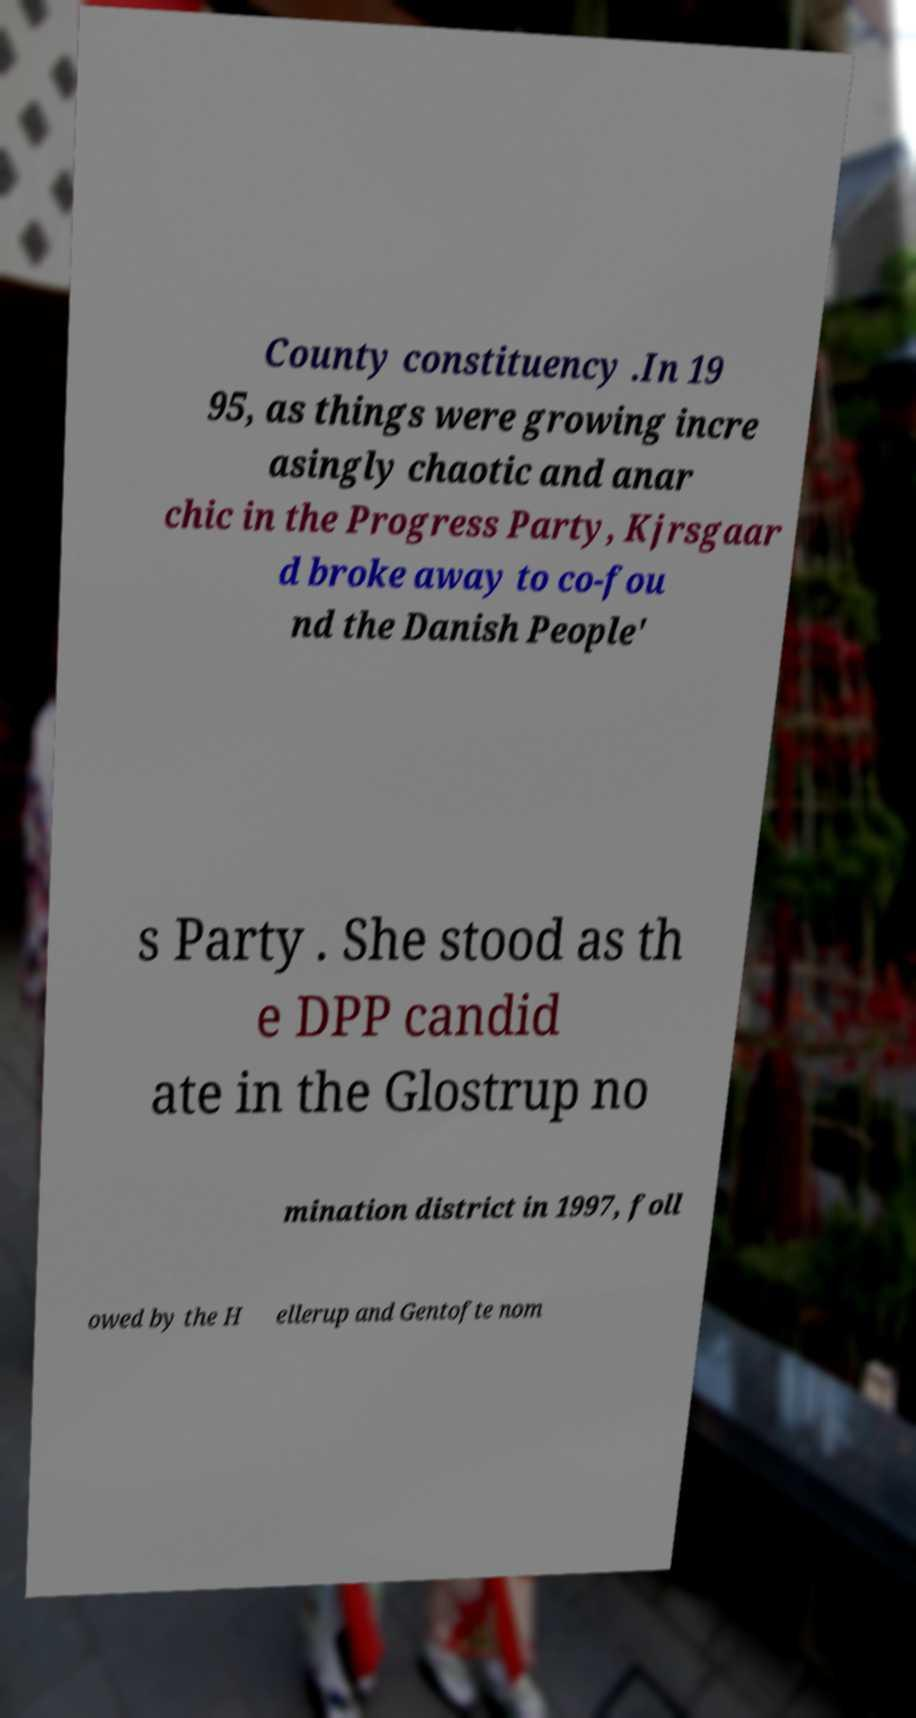Could you assist in decoding the text presented in this image and type it out clearly? County constituency .In 19 95, as things were growing incre asingly chaotic and anar chic in the Progress Party, Kjrsgaar d broke away to co-fou nd the Danish People' s Party . She stood as th e DPP candid ate in the Glostrup no mination district in 1997, foll owed by the H ellerup and Gentofte nom 